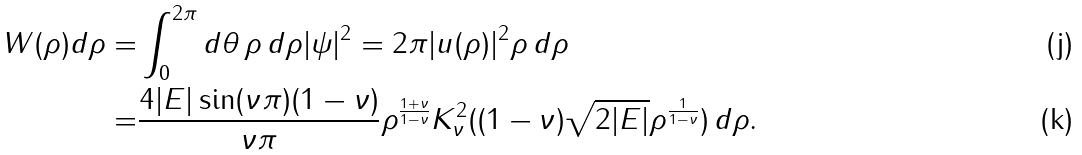Convert formula to latex. <formula><loc_0><loc_0><loc_500><loc_500>W ( \rho ) d \rho = & \int _ { 0 } ^ { 2 \pi } d \theta \, \rho \, d \rho | \psi | ^ { 2 } = 2 \pi | u ( \rho ) | ^ { 2 } \rho \, d \rho \\ = & \frac { 4 | E | \sin ( \nu \pi ) ( 1 - \nu ) } { \nu \pi } \rho ^ { \frac { 1 + \nu } { 1 - \nu } } K _ { \nu } ^ { 2 } ( ( 1 - \nu ) \sqrt { 2 | E | } \rho ^ { \frac { 1 } { 1 - \nu } } ) \, d \rho .</formula> 